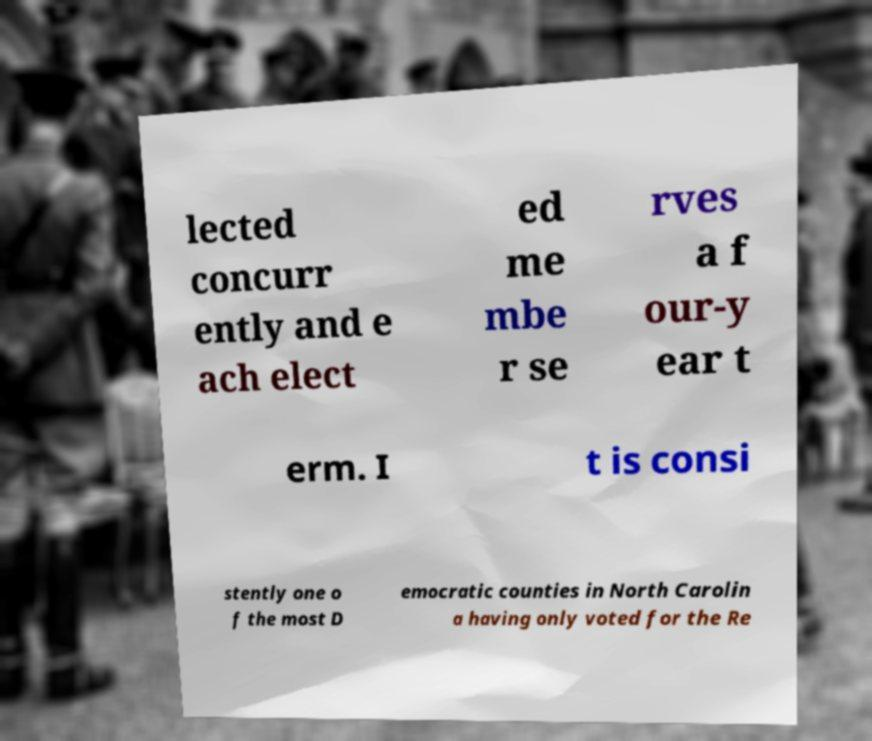Could you assist in decoding the text presented in this image and type it out clearly? lected concurr ently and e ach elect ed me mbe r se rves a f our-y ear t erm. I t is consi stently one o f the most D emocratic counties in North Carolin a having only voted for the Re 